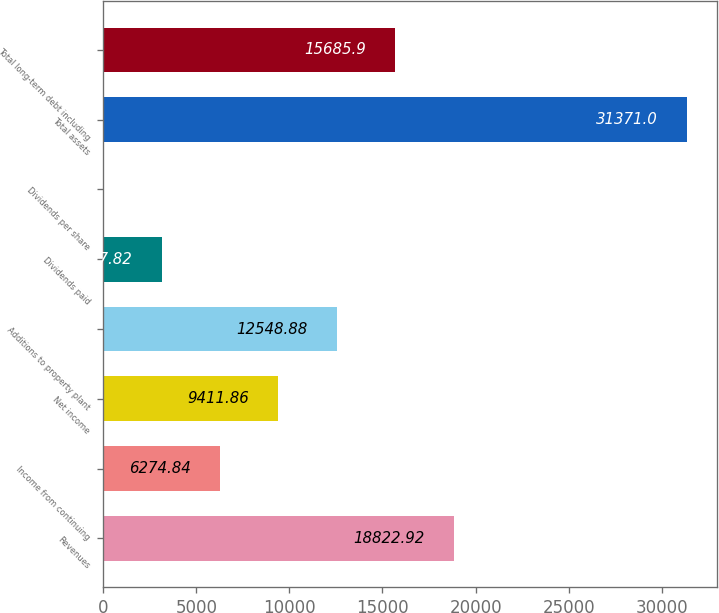Convert chart to OTSL. <chart><loc_0><loc_0><loc_500><loc_500><bar_chart><fcel>Revenues<fcel>Income from continuing<fcel>Net income<fcel>Additions to property plant<fcel>Dividends paid<fcel>Dividends per share<fcel>Total assets<fcel>Total long-term debt including<nl><fcel>18822.9<fcel>6274.84<fcel>9411.86<fcel>12548.9<fcel>3137.82<fcel>0.8<fcel>31371<fcel>15685.9<nl></chart> 